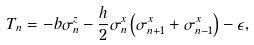<formula> <loc_0><loc_0><loc_500><loc_500>T _ { n } = - b \sigma _ { n } ^ { z } - \frac { h } { 2 } \sigma _ { n } ^ { x } \left ( \sigma _ { n + 1 } ^ { x } + \sigma _ { n - 1 } ^ { x } \right ) - \epsilon ,</formula> 